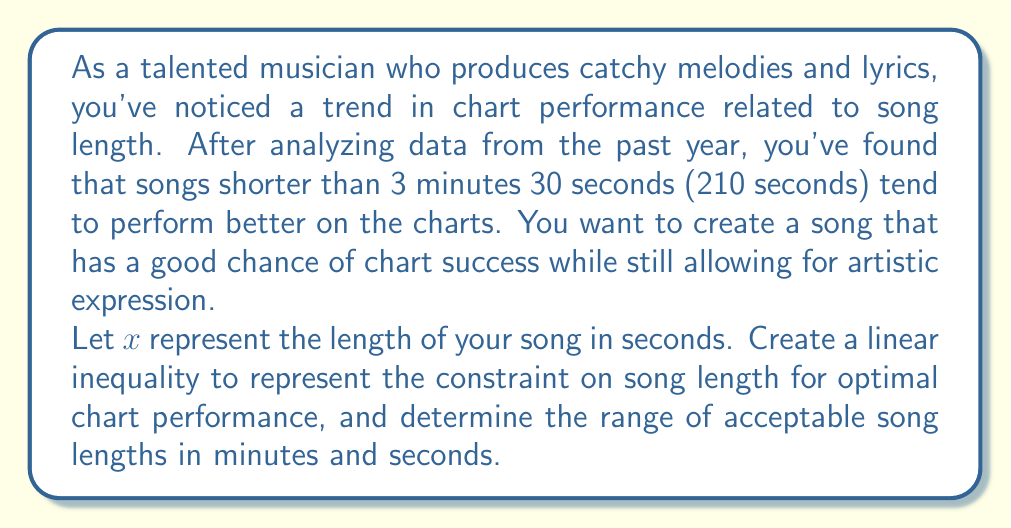Could you help me with this problem? To solve this problem, we'll follow these steps:

1) First, let's set up the linear inequality:
   Since songs shorter than 3 minutes 30 seconds (210 seconds) perform better, we can represent this as:

   $x < 210$

2) This inequality represents our constraint for optimal chart performance.

3) To find the range of acceptable song lengths, we need to consider the practical limits of song length. Let's assume a song should be at least 2 minutes (120 seconds) long:

   $120 \leq x < 210$

4) To convert this range to minutes and seconds:
   
   Lower bound: 120 seconds = 2 minutes 0 seconds
   Upper bound: 209 seconds (since x < 210) = 3 minutes 29 seconds

   We can represent this mathematically as:

   $2:00 \leq \text{song length} < 3:30$

Thus, the range of acceptable song lengths is from 2 minutes 0 seconds to 3 minutes 29 seconds.
Answer: The linear inequality representing the constraint on song length is $x < 210$, where $x$ is the song length in seconds. The range of acceptable song lengths is $2:00 \leq \text{song length} < 3:30$ (from 2 minutes 0 seconds to 3 minutes 29 seconds). 